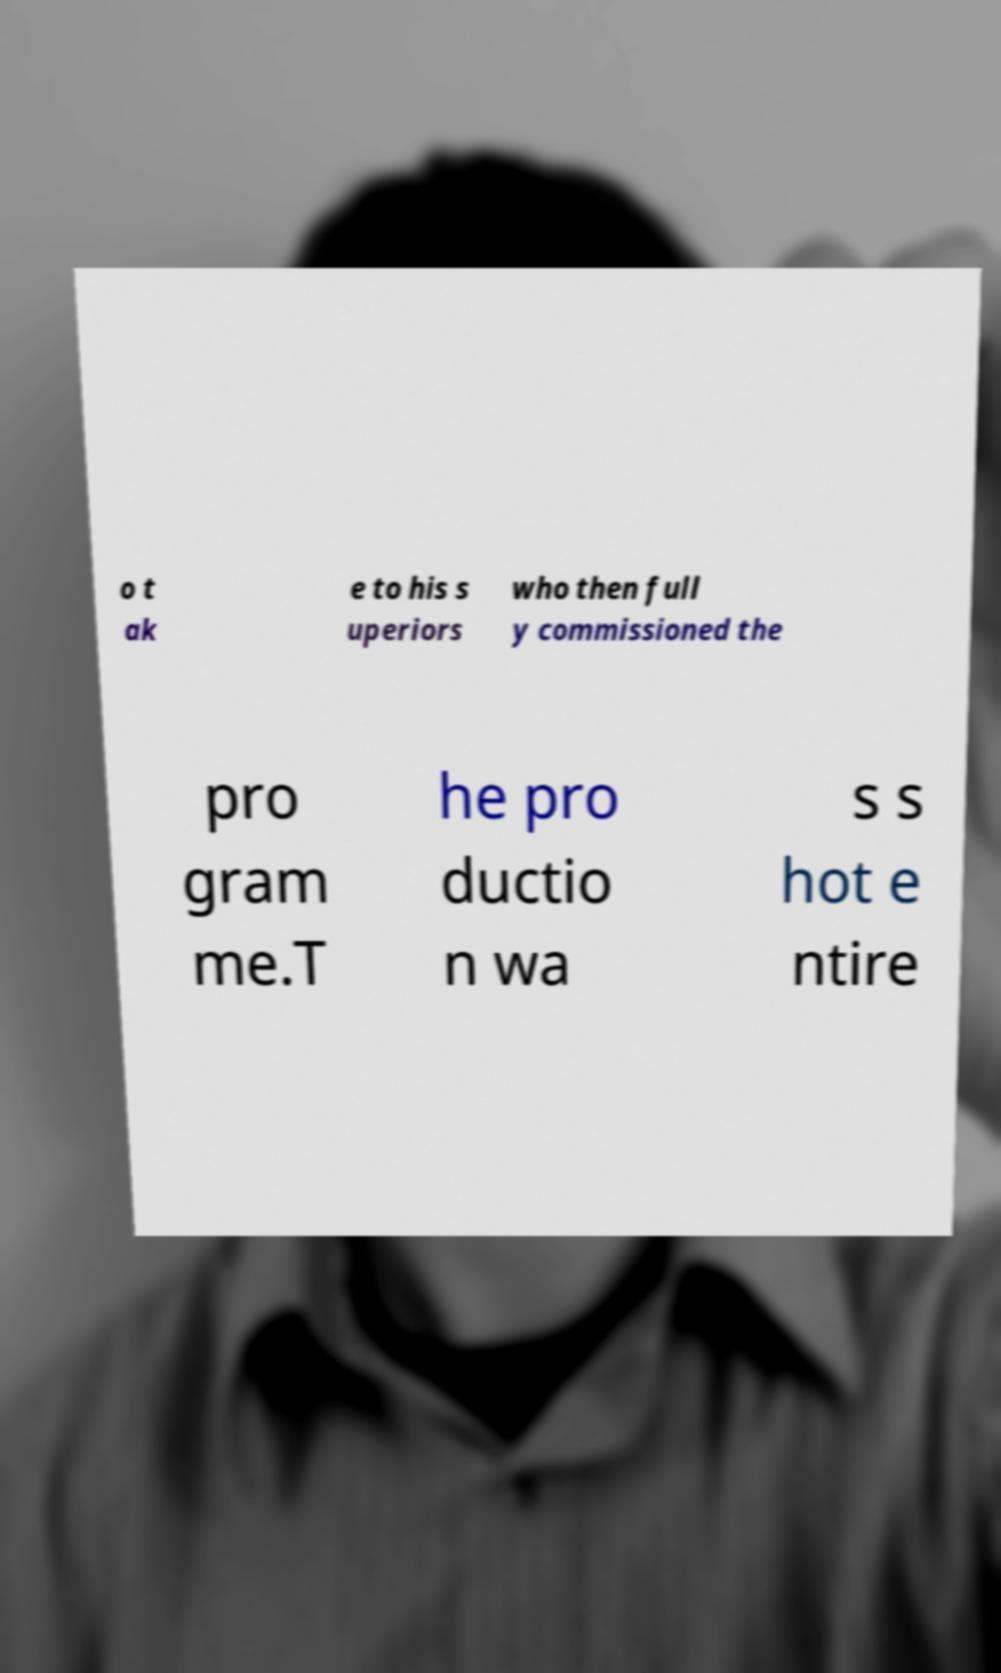Could you extract and type out the text from this image? o t ak e to his s uperiors who then full y commissioned the pro gram me.T he pro ductio n wa s s hot e ntire 